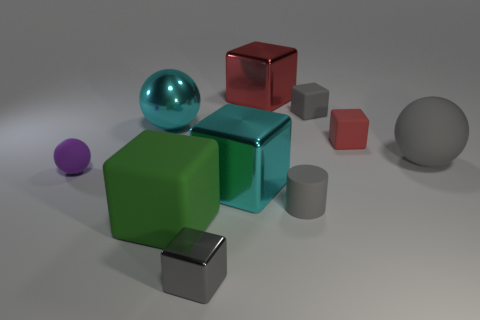What number of other objects are the same size as the green object?
Provide a succinct answer. 4. How many tiny cylinders are there?
Offer a very short reply. 1. Does the purple thing have the same size as the gray sphere?
Keep it short and to the point. No. What number of other things are the same shape as the large green matte object?
Give a very brief answer. 5. What material is the large sphere in front of the large cyan metallic object left of the big cyan metallic cube?
Provide a succinct answer. Rubber. There is a red shiny thing; are there any tiny gray objects on the right side of it?
Keep it short and to the point. Yes. There is a red shiny cube; is its size the same as the ball that is right of the green block?
Give a very brief answer. Yes. There is a cyan object that is the same shape as the small gray metallic thing; what size is it?
Make the answer very short. Large. Is there anything else that has the same material as the cyan cube?
Provide a succinct answer. Yes. There is a gray cube that is in front of the tiny ball; does it have the same size as the object to the right of the small red block?
Ensure brevity in your answer.  No. 